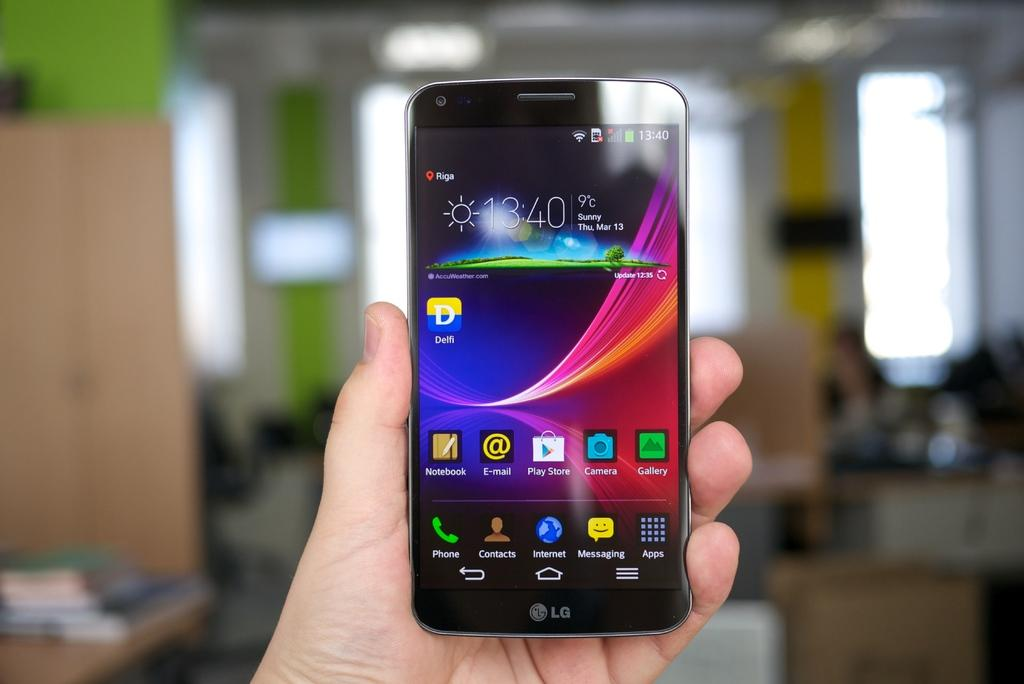Provide a one-sentence caption for the provided image. An LG phone being held in the library with the time at 13:40 on March 13th. 